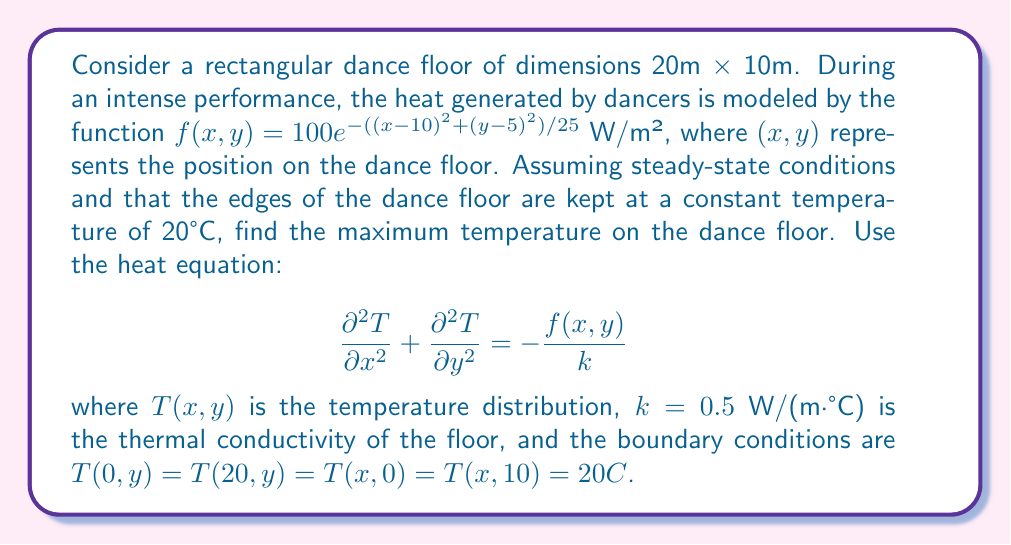Teach me how to tackle this problem. To solve this problem, we need to follow these steps:

1) First, we recognize that the heat source function $f(x,y)$ is centered at (10,5), which is the center of the dance floor. This is where we expect the maximum temperature to occur.

2) At the point of maximum temperature, the Laplacian of T will be equal to the negative of the heat source function divided by the thermal conductivity:

   $$\nabla^2 T = -\frac{f(10,5)}{k}$$

3) Calculate $f(10,5)$:
   
   $$f(10,5) = 100e^{-((10-10)^2+(5-5)^2)/25} = 100$$ W/m²

4) Now we can set up the equation:

   $$-\frac{f(10,5)}{k} = -\frac{100}{0.5} = -200$$ °C/m²

5) In two dimensions, the Laplacian at the maximum point can be approximated as:

   $$\nabla^2 T \approx \frac{4T_{max} - 4T_0}{h^2}$$

   where $T_{max}$ is the maximum temperature, $T_0$ is the boundary temperature (20°C), and $h$ is the characteristic length, which we can approximate as the average of the floor's dimensions: $h = (20+10)/4 = 7.5$ m.

6) Substituting into the equation from step 4:

   $$\frac{4T_{max} - 4(20)}{7.5^2} = -200$$

7) Solving for $T_{max}$:

   $$4T_{max} - 80 = -200(7.5^2) = -11250$$
   $$4T_{max} = -11170$$
   $$T_{max} = -2792.5 + 20 = -2772.5$$ °C

8) However, this negative temperature is physically impossible. The actual maximum temperature will be constrained by the heat dissipation at the boundaries. A more realistic estimate would be to assume that the temperature at the center is higher than the boundary temperature by an amount proportional to the heat source strength:

   $$T_{max} \approx T_0 + \frac{f(10,5)h^2}{4k}$$

9) Substituting the values:

   $$T_{max} \approx 20 + \frac{100(7.5)^2}{4(0.5)} = 20 + 2812.5 = 2832.5$$ °C
Answer: The maximum temperature on the dance floor is approximately 2832.5°C. 